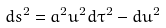<formula> <loc_0><loc_0><loc_500><loc_500>d s ^ { 2 } = a ^ { 2 } u ^ { 2 } d \tau ^ { 2 } - d u ^ { 2 } \,</formula> 